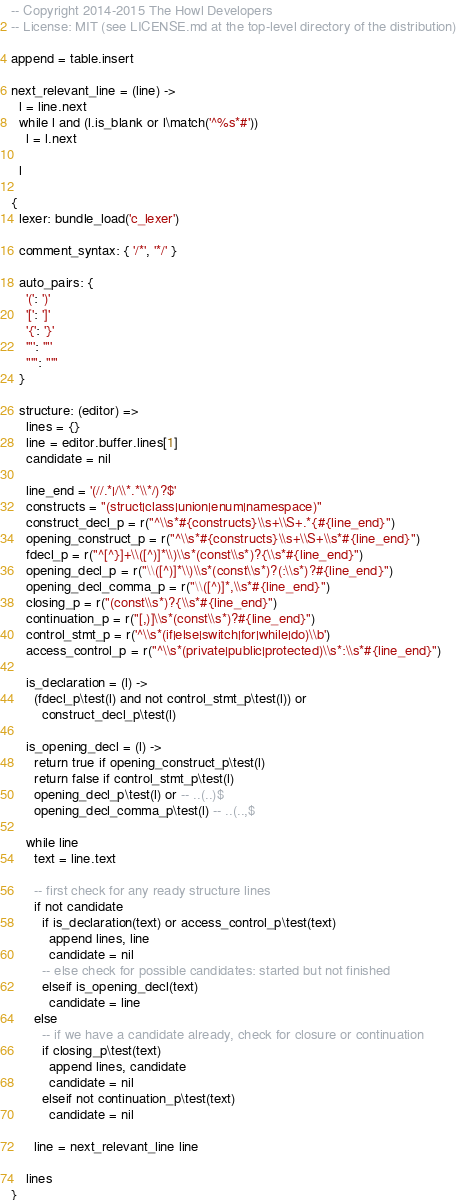<code> <loc_0><loc_0><loc_500><loc_500><_MoonScript_>-- Copyright 2014-2015 The Howl Developers
-- License: MIT (see LICENSE.md at the top-level directory of the distribution)

append = table.insert

next_relevant_line = (line) ->
  l = line.next
  while l and (l.is_blank or l\match('^%s*#'))
    l = l.next

  l

{
  lexer: bundle_load('c_lexer')

  comment_syntax: { '/*', '*/' }

  auto_pairs: {
    '(': ')'
    '[': ']'
    '{': '}'
    '"': '"'
    "'": "'"
  }

  structure: (editor) =>
    lines = {}
    line = editor.buffer.lines[1]
    candidate = nil

    line_end = '(//.*|/\\*.*\\*/)?$'
    constructs = "(struct|class|union|enum|namespace)"
    construct_decl_p = r("^\\s*#{constructs}\\s+\\S+.*{#{line_end}")
    opening_construct_p = r("^\\s*#{constructs}\\s+\\S+\\s*#{line_end}")
    fdecl_p = r("^[^}]+\\([^)]*\\)\\s*(const\\s*)?{\\s*#{line_end}")
    opening_decl_p = r("\\([^)]*\\)\\s*(const\\s*)?(:\\s*)?#{line_end}")
    opening_decl_comma_p = r("\\([^)]*,\\s*#{line_end}")
    closing_p = r("(const\\s*)?{\\s*#{line_end}")
    continuation_p = r("[,)]\\s*(const\\s*)?#{line_end}")
    control_stmt_p = r('^\\s*(if|else|switch|for|while|do)\\b')
    access_control_p = r("^\\s*(private|public|protected)\\s*:\\s*#{line_end}")

    is_declaration = (l) ->
      (fdecl_p\test(l) and not control_stmt_p\test(l)) or
        construct_decl_p\test(l)

    is_opening_decl = (l) ->
      return true if opening_construct_p\test(l)
      return false if control_stmt_p\test(l)
      opening_decl_p\test(l) or -- ..(..)$
      opening_decl_comma_p\test(l) -- ..(..,$

    while line
      text = line.text

      -- first check for any ready structure lines
      if not candidate
        if is_declaration(text) or access_control_p\test(text)
          append lines, line
          candidate = nil
        -- else check for possible candidates: started but not finished
        elseif is_opening_decl(text)
          candidate = line
      else
        -- if we have a candidate already, check for closure or continuation
        if closing_p\test(text)
          append lines, candidate
          candidate = nil
        elseif not continuation_p\test(text)
          candidate = nil

      line = next_relevant_line line

    lines
}
</code> 